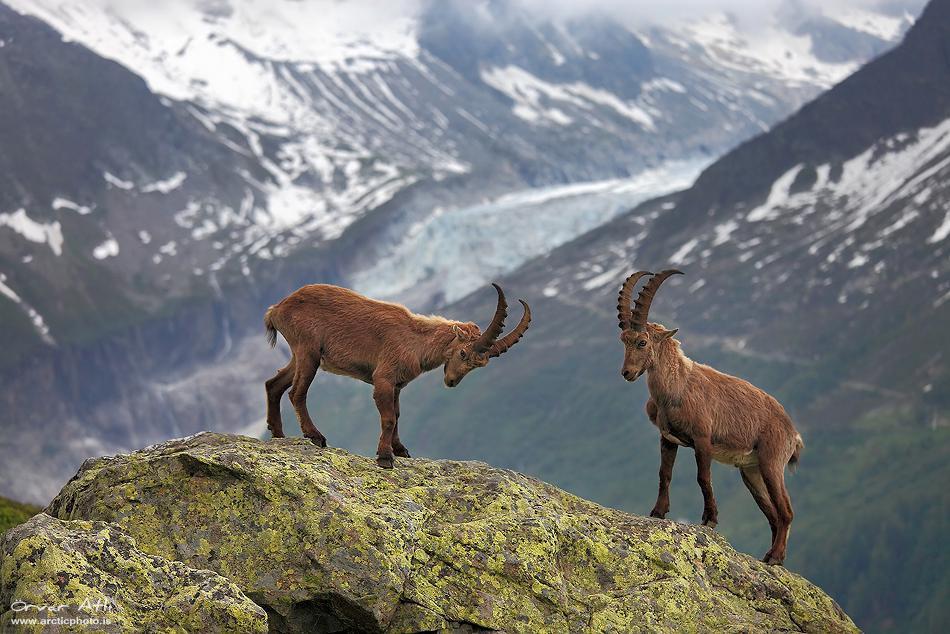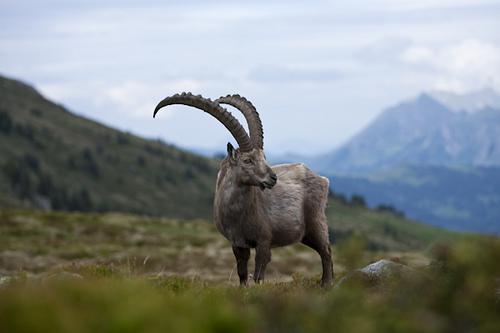The first image is the image on the left, the second image is the image on the right. Given the left and right images, does the statement "An image shows exactly one horned animal, which stands with body angled leftward and head angled rightward." hold true? Answer yes or no. Yes. The first image is the image on the left, the second image is the image on the right. For the images shown, is this caption "There are three antelopes in total." true? Answer yes or no. Yes. 